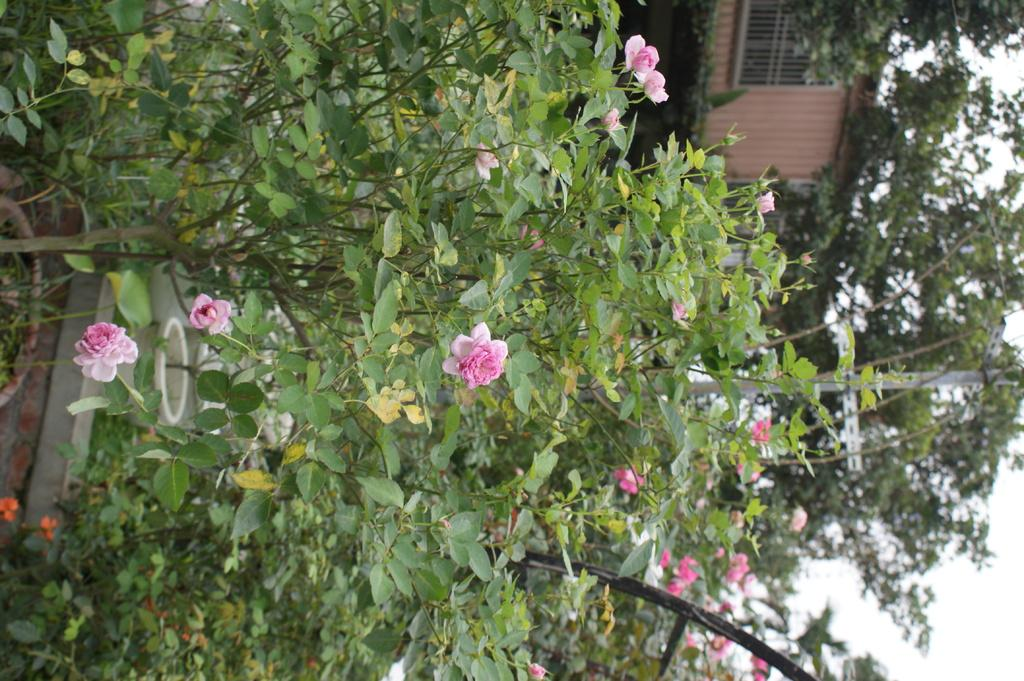What type of plant can be seen in the image? There is a flower plant in the image. What are the flower pots used for in the image? The flower pots are used to hold the flower plants in the image. What type of vegetation is present in the image besides the flower plant? There is a tree in the image. What structure is visible in the image? There is a house in the image. What part of the natural environment is visible in the image? Some part of the sky is visible in the image. How many bears are visible in the image? There are no bears present in the image. What type of property is being sold in the image? There is no indication of any property being sold in the image. 